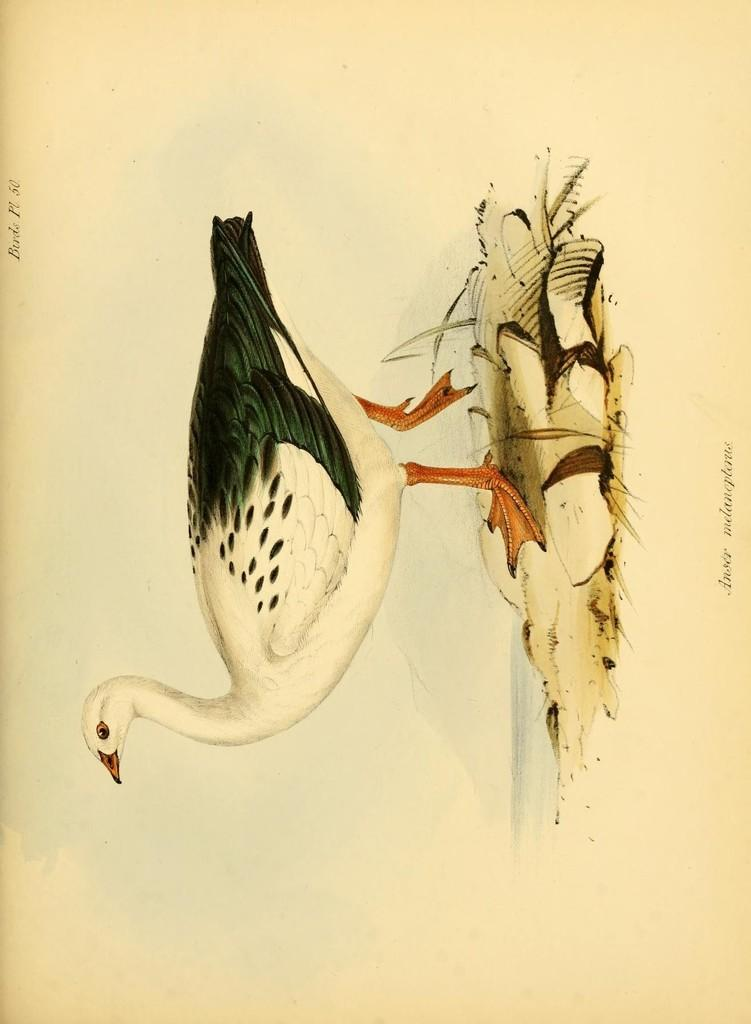What is present on the paper in the image? There is a drawing on the paper. Can you describe the drawing on the paper? Unfortunately, the details of the drawing cannot be determined from the provided facts. What is the primary purpose of the paper in the image? The primary purpose of the paper in the image is to display the drawing. How does the earthquake affect the drawing on the paper in the image? There is no earthquake present in the image, so its effects on the drawing cannot be determined. 